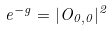Convert formula to latex. <formula><loc_0><loc_0><loc_500><loc_500>e ^ { - g } = | O _ { 0 , 0 } | ^ { 2 }</formula> 